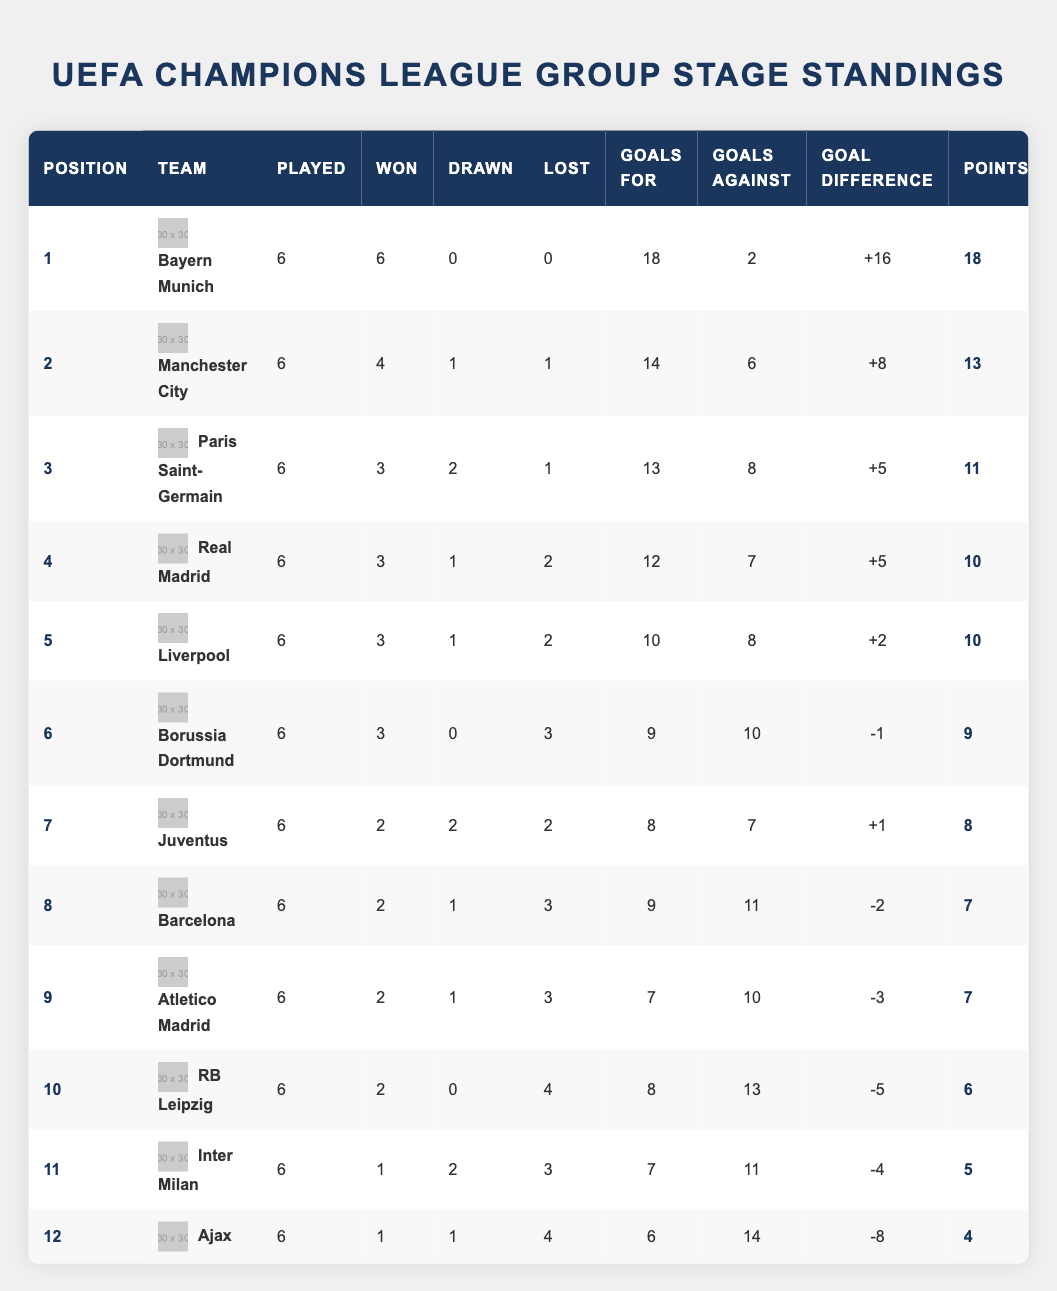What team has the highest points in the group stage? Bayern Munich is listed as the team in position 1 with 18 points, which is the highest among all teams in the table.
Answer: Bayern Munich How many goals did Manchester City score during the group phase? The table shows that Manchester City scored 14 goals as indicated in the 'Goals For' column.
Answer: 14 Did Bahia Munich lose any matches in the group stage? Bayern Munich’s record shows that they won all their matches with 6 wins and 0 losses, meaning they did not lose any matches.
Answer: No What is the goal difference for Paris Saint-Germain? The goal difference for Paris Saint-Germain is listed as +5 in the table, which is found under the 'Goal Difference' column.
Answer: +5 Which team has the lowest points and how many points did they have? Ajax is in the last position (12th) with 4 points, as shown in the 'Points' column.
Answer: Ajax, 4 points How many total matches did all teams play in the group stage? Each of the 12 teams played 6 matches which sums up to a total of (12 teams x 6 matches) = 72 matches played in the group stage.
Answer: 72 matches What is the average number of goals scored by teams in this table? To find the average, sum up all 'Goals For' values: 18 + 14 + 13 + 12 + 10 + 9 + 8 + 9 + 7 + 8 + 7 + 6 =  8 + 10 + 9 + 6 = 84. Then divide by 12 (number of teams) which equals 84 / 12 = 7.
Answer: 7 goals What is the total number of matches lost by Juventus and Atletico Madrid combined? Juventus lost 2 matches and Atletico Madrid lost 3. Adding these gives a total of (2 + 3) = 5 matches lost.
Answer: 5 matches Which teams have a positive goal difference and how many are there? The teams with positive goal differences are Bayern Munich (+16), Manchester City (+8), Paris Saint-Germain (+5), Real Madrid (+5), Liverpool (+2), and Juventus (+1). There are 6 teams with positive goal differences.
Answer: 6 teams 